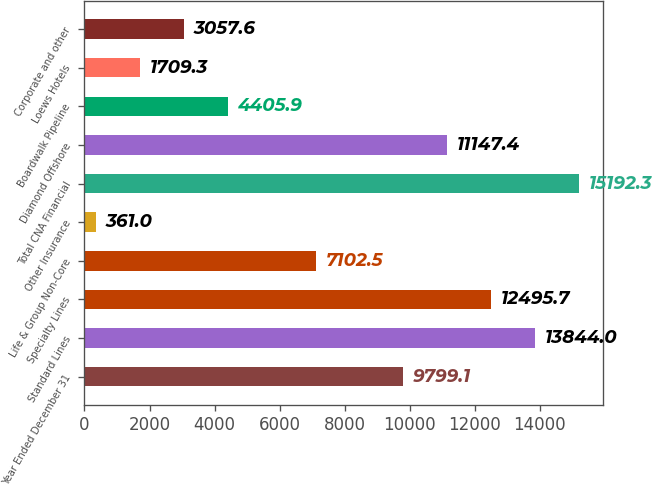<chart> <loc_0><loc_0><loc_500><loc_500><bar_chart><fcel>Year Ended December 31<fcel>Standard Lines<fcel>Specialty Lines<fcel>Life & Group Non-Core<fcel>Other Insurance<fcel>Total CNA Financial<fcel>Diamond Offshore<fcel>Boardwalk Pipeline<fcel>Loews Hotels<fcel>Corporate and other<nl><fcel>9799.1<fcel>13844<fcel>12495.7<fcel>7102.5<fcel>361<fcel>15192.3<fcel>11147.4<fcel>4405.9<fcel>1709.3<fcel>3057.6<nl></chart> 